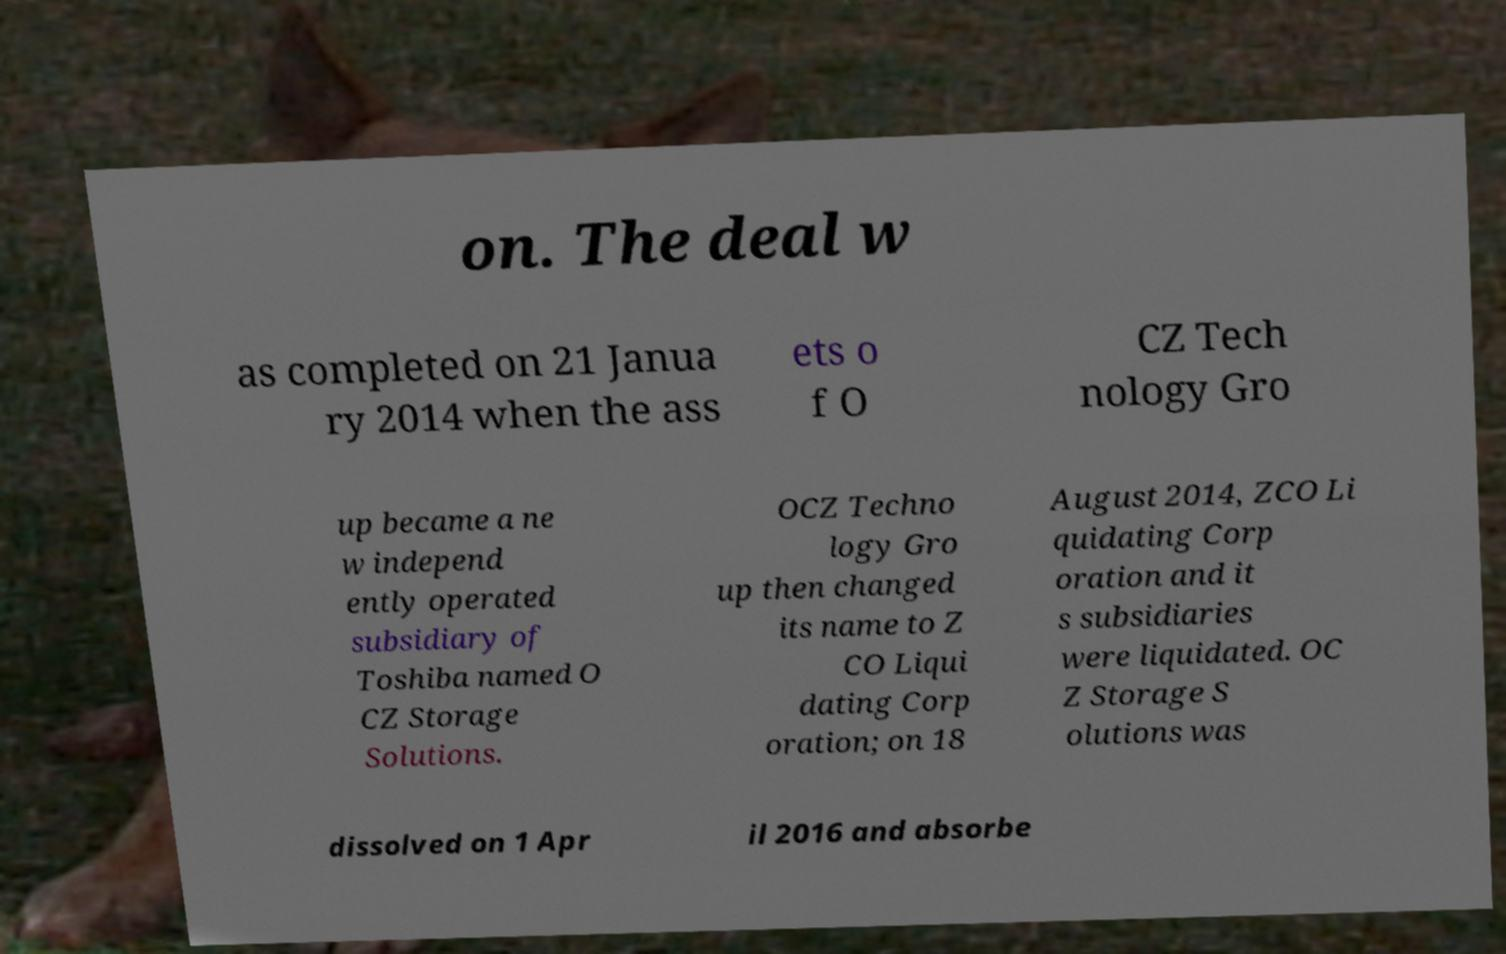Please read and relay the text visible in this image. What does it say? on. The deal w as completed on 21 Janua ry 2014 when the ass ets o f O CZ Tech nology Gro up became a ne w independ ently operated subsidiary of Toshiba named O CZ Storage Solutions. OCZ Techno logy Gro up then changed its name to Z CO Liqui dating Corp oration; on 18 August 2014, ZCO Li quidating Corp oration and it s subsidiaries were liquidated. OC Z Storage S olutions was dissolved on 1 Apr il 2016 and absorbe 